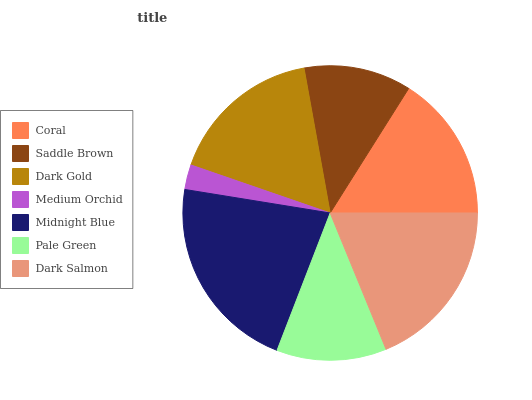Is Medium Orchid the minimum?
Answer yes or no. Yes. Is Midnight Blue the maximum?
Answer yes or no. Yes. Is Saddle Brown the minimum?
Answer yes or no. No. Is Saddle Brown the maximum?
Answer yes or no. No. Is Coral greater than Saddle Brown?
Answer yes or no. Yes. Is Saddle Brown less than Coral?
Answer yes or no. Yes. Is Saddle Brown greater than Coral?
Answer yes or no. No. Is Coral less than Saddle Brown?
Answer yes or no. No. Is Coral the high median?
Answer yes or no. Yes. Is Coral the low median?
Answer yes or no. Yes. Is Dark Gold the high median?
Answer yes or no. No. Is Pale Green the low median?
Answer yes or no. No. 